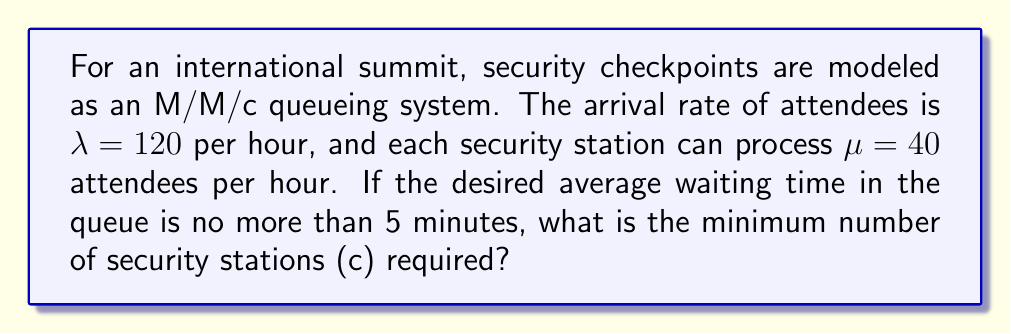What is the answer to this math problem? To solve this problem, we'll use the M/M/c queueing model and follow these steps:

1) First, we need to calculate the utilization factor $\rho$:
   $\rho = \frac{\lambda}{c\mu}$

2) For stability, we require $\rho < 1$, so:
   $\frac{120}{c(40)} < 1$
   $c > 3$

3) The average waiting time in the queue for an M/M/c system is given by:
   $W_q = \frac{P_0(\lambda/\mu)^c}{c!(c\mu-\lambda)^2} \cdot \frac{\mu c}{c!}$

   Where $P_0$ is the probability of an empty system:
   $P_0 = [\sum_{n=0}^{c-1}\frac{(\lambda/\mu)^n}{n!} + \frac{(\lambda/\mu)^c}{c!(1-\rho)}]^{-1}$

4) We want $W_q \leq 5$ minutes = $\frac{1}{12}$ hour

5) Starting with $c = 4$ (as $c$ must be greater than 3), we calculate:
   $\rho = \frac{120}{4(40)} = 0.75$
   
   $P_0 = [\sum_{n=0}^{3}\frac{(120/40)^n}{n!} + \frac{(120/40)^4}{4!(1-0.75)}]^{-1} = 0.0398$

   $W_q = \frac{0.0398(120/40)^4}{4!(4(40)-120)^2} \cdot \frac{40(4)}{4!} = 0.1406$ hours

6) This is greater than $\frac{1}{12}$ hour, so we try $c = 5$:
   $\rho = \frac{120}{5(40)} = 0.6$
   
   $P_0 = [\sum_{n=0}^{4}\frac{(120/40)^n}{n!} + \frac{(120/40)^5}{5!(1-0.6)}]^{-1} = 0.0446$

   $W_q = \frac{0.0446(120/40)^5}{5!(5(40)-120)^2} \cdot \frac{40(5)}{5!} = 0.0304$ hours

7) This is less than $\frac{1}{12}$ hour, so 5 security stations are sufficient.
Answer: 5 security stations 